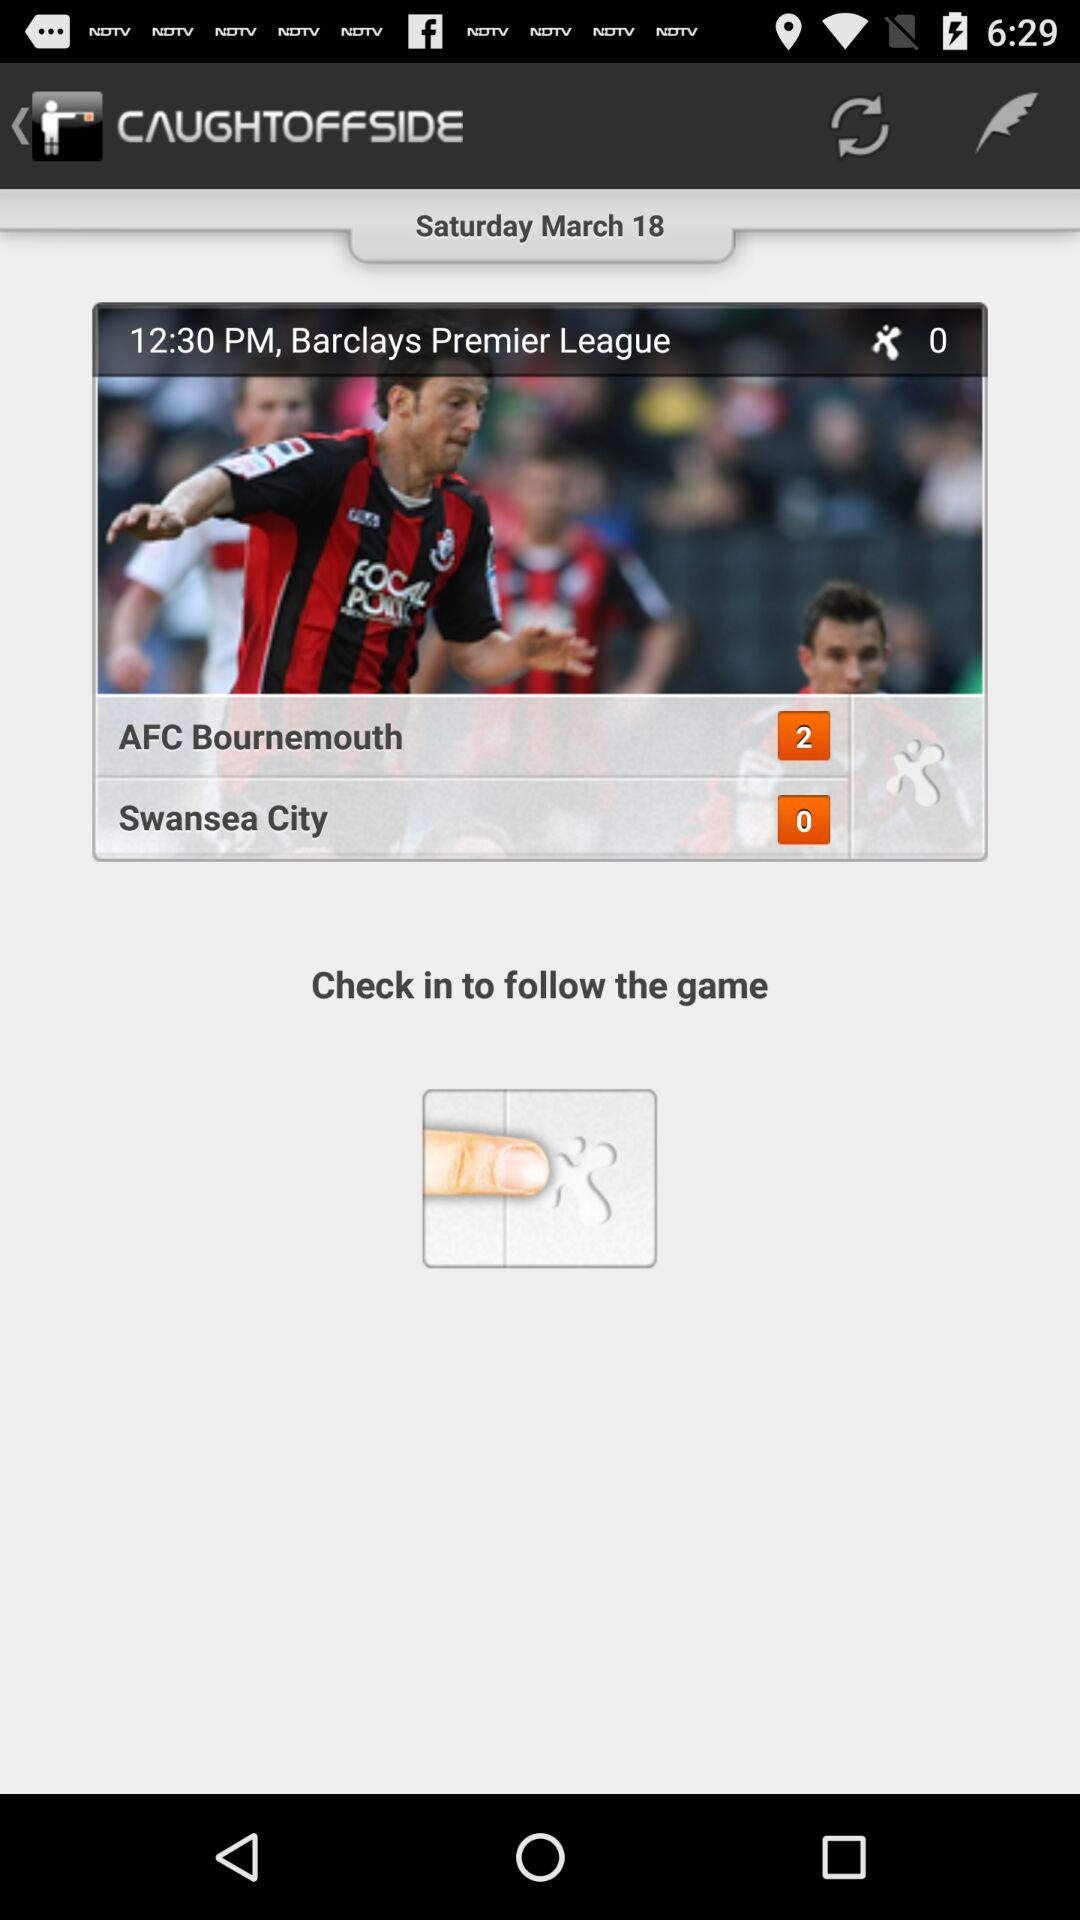How many more goals did AFC Bournemouth score than Swansea City?
Answer the question using a single word or phrase. 2 